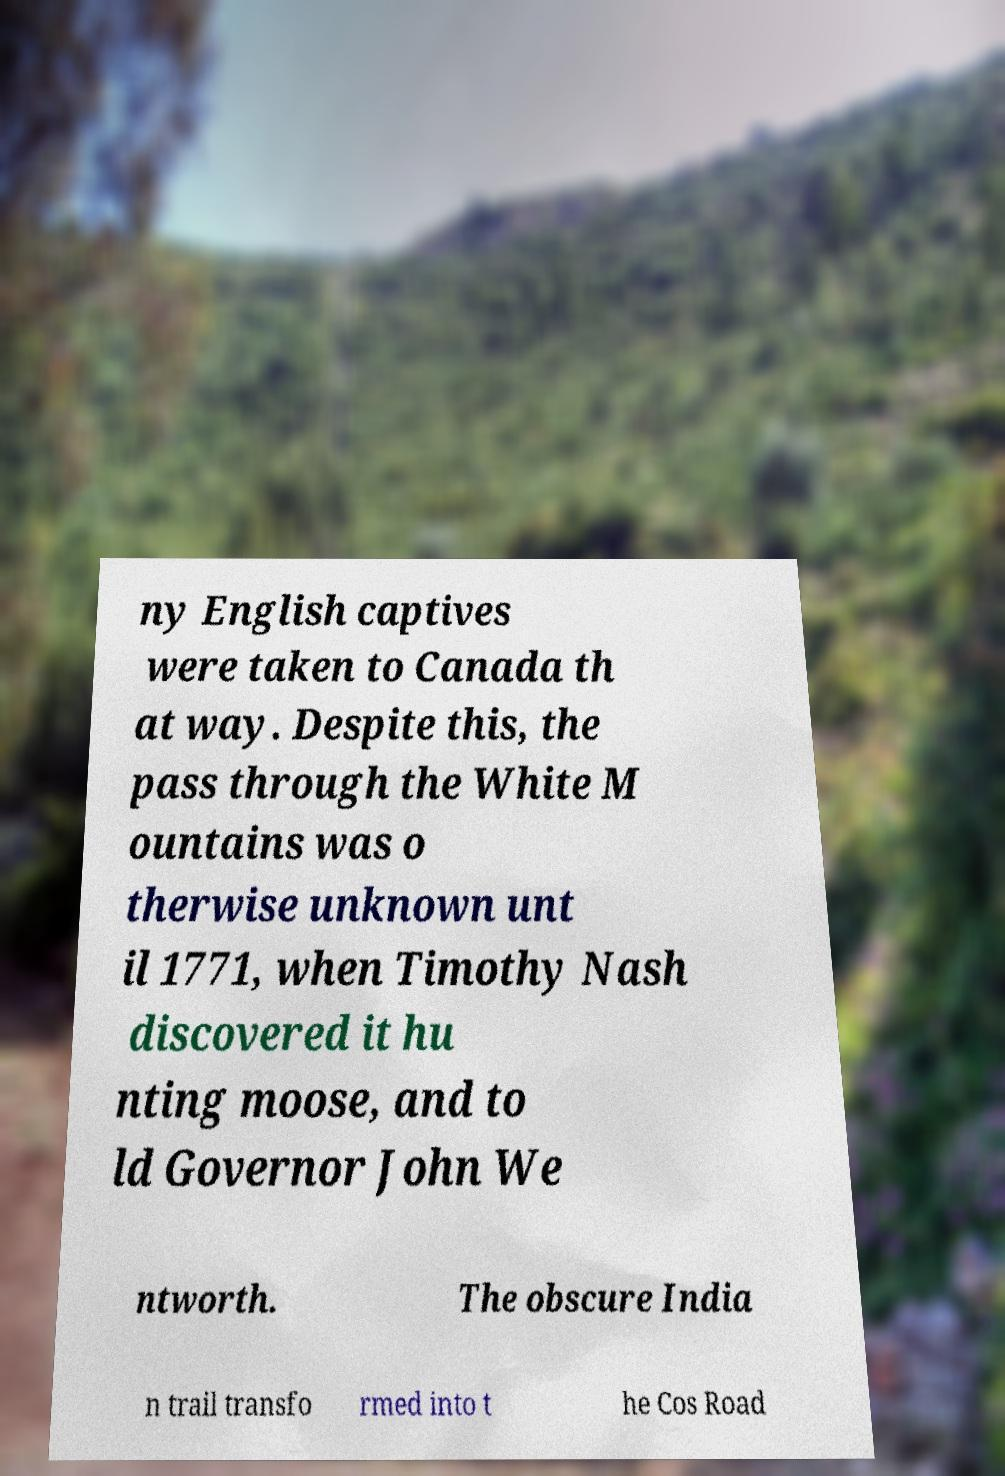I need the written content from this picture converted into text. Can you do that? ny English captives were taken to Canada th at way. Despite this, the pass through the White M ountains was o therwise unknown unt il 1771, when Timothy Nash discovered it hu nting moose, and to ld Governor John We ntworth. The obscure India n trail transfo rmed into t he Cos Road 